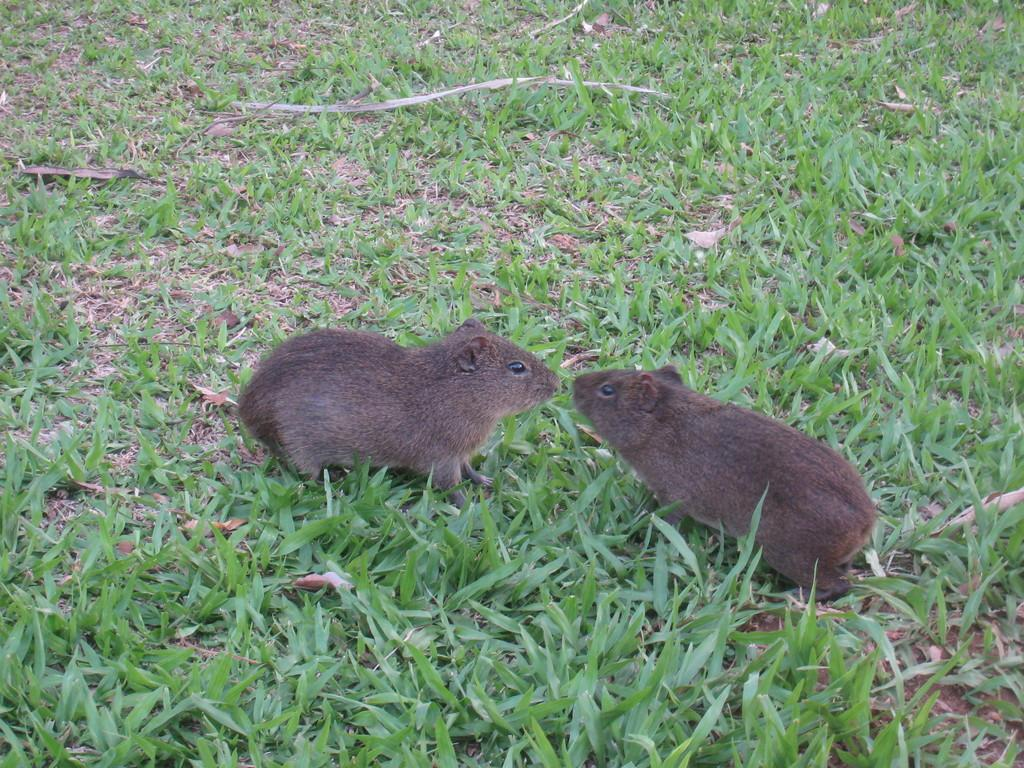What animals are in the image? There are two rats in the image. Where are the rats located? The rats are on the grass. What other elements can be seen in the image? Dry leaves are present in the image. What type of company is responsible for the fog in the image? There is no fog present in the image, so it is not possible to determine which company might be responsible. 